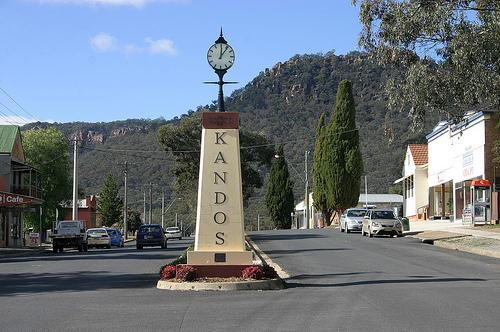Question: when was this photo taken?
Choices:
A. 4:00.
B. 12:05.
C. 3:00.
D. 9:00.
Answer with the letter. Answer: B Question: how many cars?
Choices:
A. One.
B. Five.
C. Seven.
D. Nine.
Answer with the letter. Answer: C Question: what color are the leaves on the trees?
Choices:
A. Blue.
B. Red.
C. Orange.
D. Green.
Answer with the letter. Answer: D Question: what type of business is in the green roofed building?
Choices:
A. Clothing store.
B. Restaurant.
C. Book store.
D. A Cafe.
Answer with the letter. Answer: D 